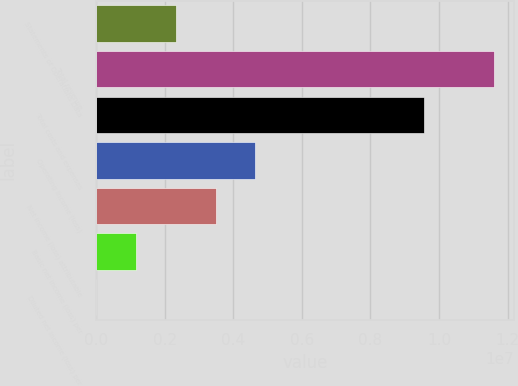Convert chart. <chart><loc_0><loc_0><loc_500><loc_500><bar_chart><fcel>Statements of Operations Data<fcel>Total revenue<fcel>Total costs and expenses<fcel>Operating income (loss)<fcel>Net income (loss) attributable<fcel>Basic net income (loss) per<fcel>Diluted net income (loss) per<nl><fcel>2.32344e+06<fcel>1.16172e+07<fcel>9.56101e+06<fcel>4.64688e+06<fcel>3.48516e+06<fcel>1.16172e+06<fcel>1.98<nl></chart> 